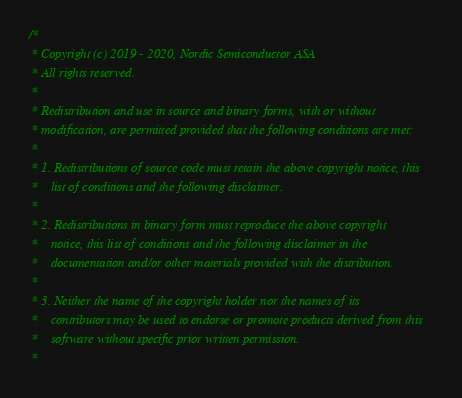Convert code to text. <code><loc_0><loc_0><loc_500><loc_500><_C_>/*
 * Copyright (c) 2019 - 2020, Nordic Semiconductor ASA
 * All rights reserved.
 *
 * Redistribution and use in source and binary forms, with or without
 * modification, are permitted provided that the following conditions are met:
 *
 * 1. Redistributions of source code must retain the above copyright notice, this
 *    list of conditions and the following disclaimer.
 *
 * 2. Redistributions in binary form must reproduce the above copyright
 *    notice, this list of conditions and the following disclaimer in the
 *    documentation and/or other materials provided with the distribution.
 *
 * 3. Neither the name of the copyright holder nor the names of its
 *    contributors may be used to endorse or promote products derived from this
 *    software without specific prior written permission.
 *</code> 